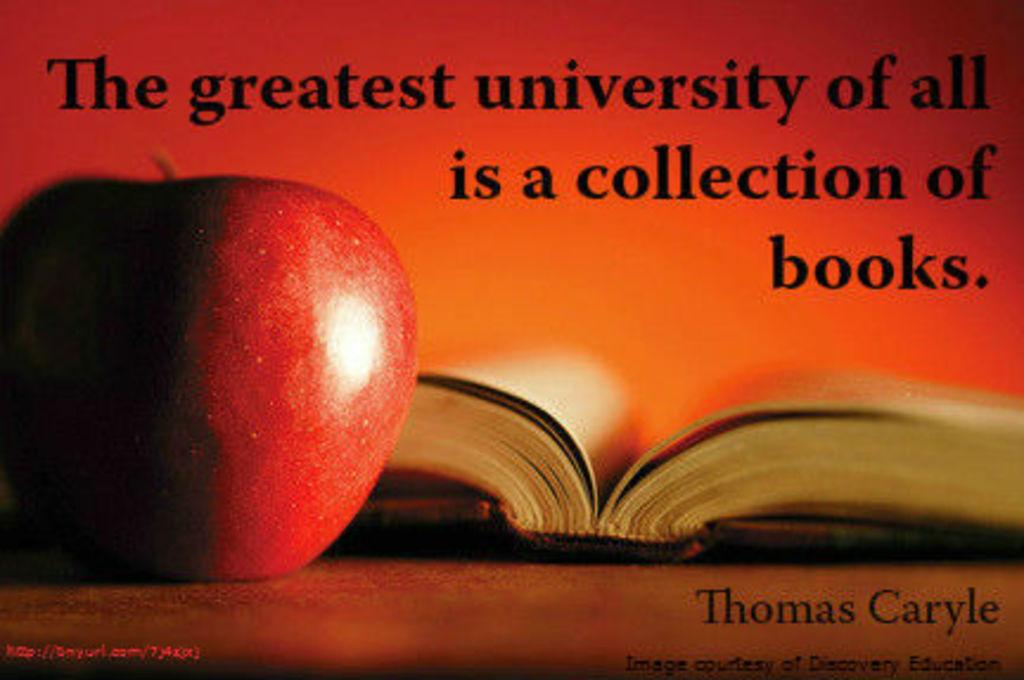Provide a one-sentence caption for the provided image. A poster showing an apple and an open book carries a inspirational quote by Thomas Carlyle. 